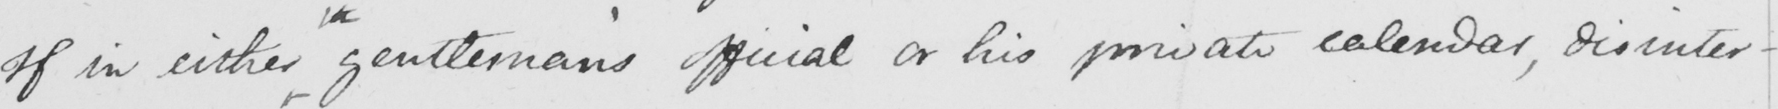What text is written in this handwritten line? If in either gentleman ' s official or his private calendar , disinter- 